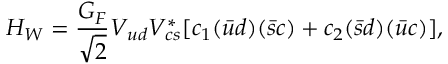Convert formula to latex. <formula><loc_0><loc_0><loc_500><loc_500>H _ { W } = { \frac { G _ { F } } { \sqrt { 2 } } } V _ { u d } V _ { c s } ^ { * } [ c _ { 1 } ( \bar { u } d ) ( \bar { s } c ) + c _ { 2 } ( \bar { s } d ) ( \bar { u } c ) ] ,</formula> 